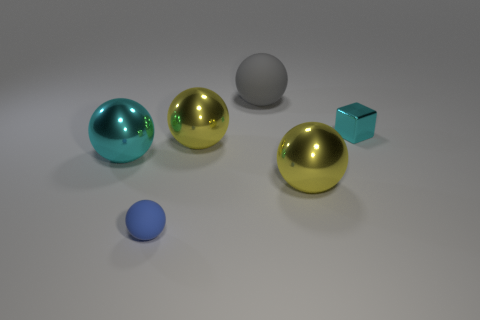Subtract all gray spheres. How many spheres are left? 4 Subtract all gray matte spheres. How many spheres are left? 4 Add 4 cyan shiny balls. How many objects exist? 10 Subtract all green spheres. Subtract all red cylinders. How many spheres are left? 5 Subtract all blocks. How many objects are left? 5 Add 5 small blue rubber spheres. How many small blue rubber spheres are left? 6 Add 4 rubber objects. How many rubber objects exist? 6 Subtract 1 yellow spheres. How many objects are left? 5 Subtract all tiny blue metal cubes. Subtract all cyan balls. How many objects are left? 5 